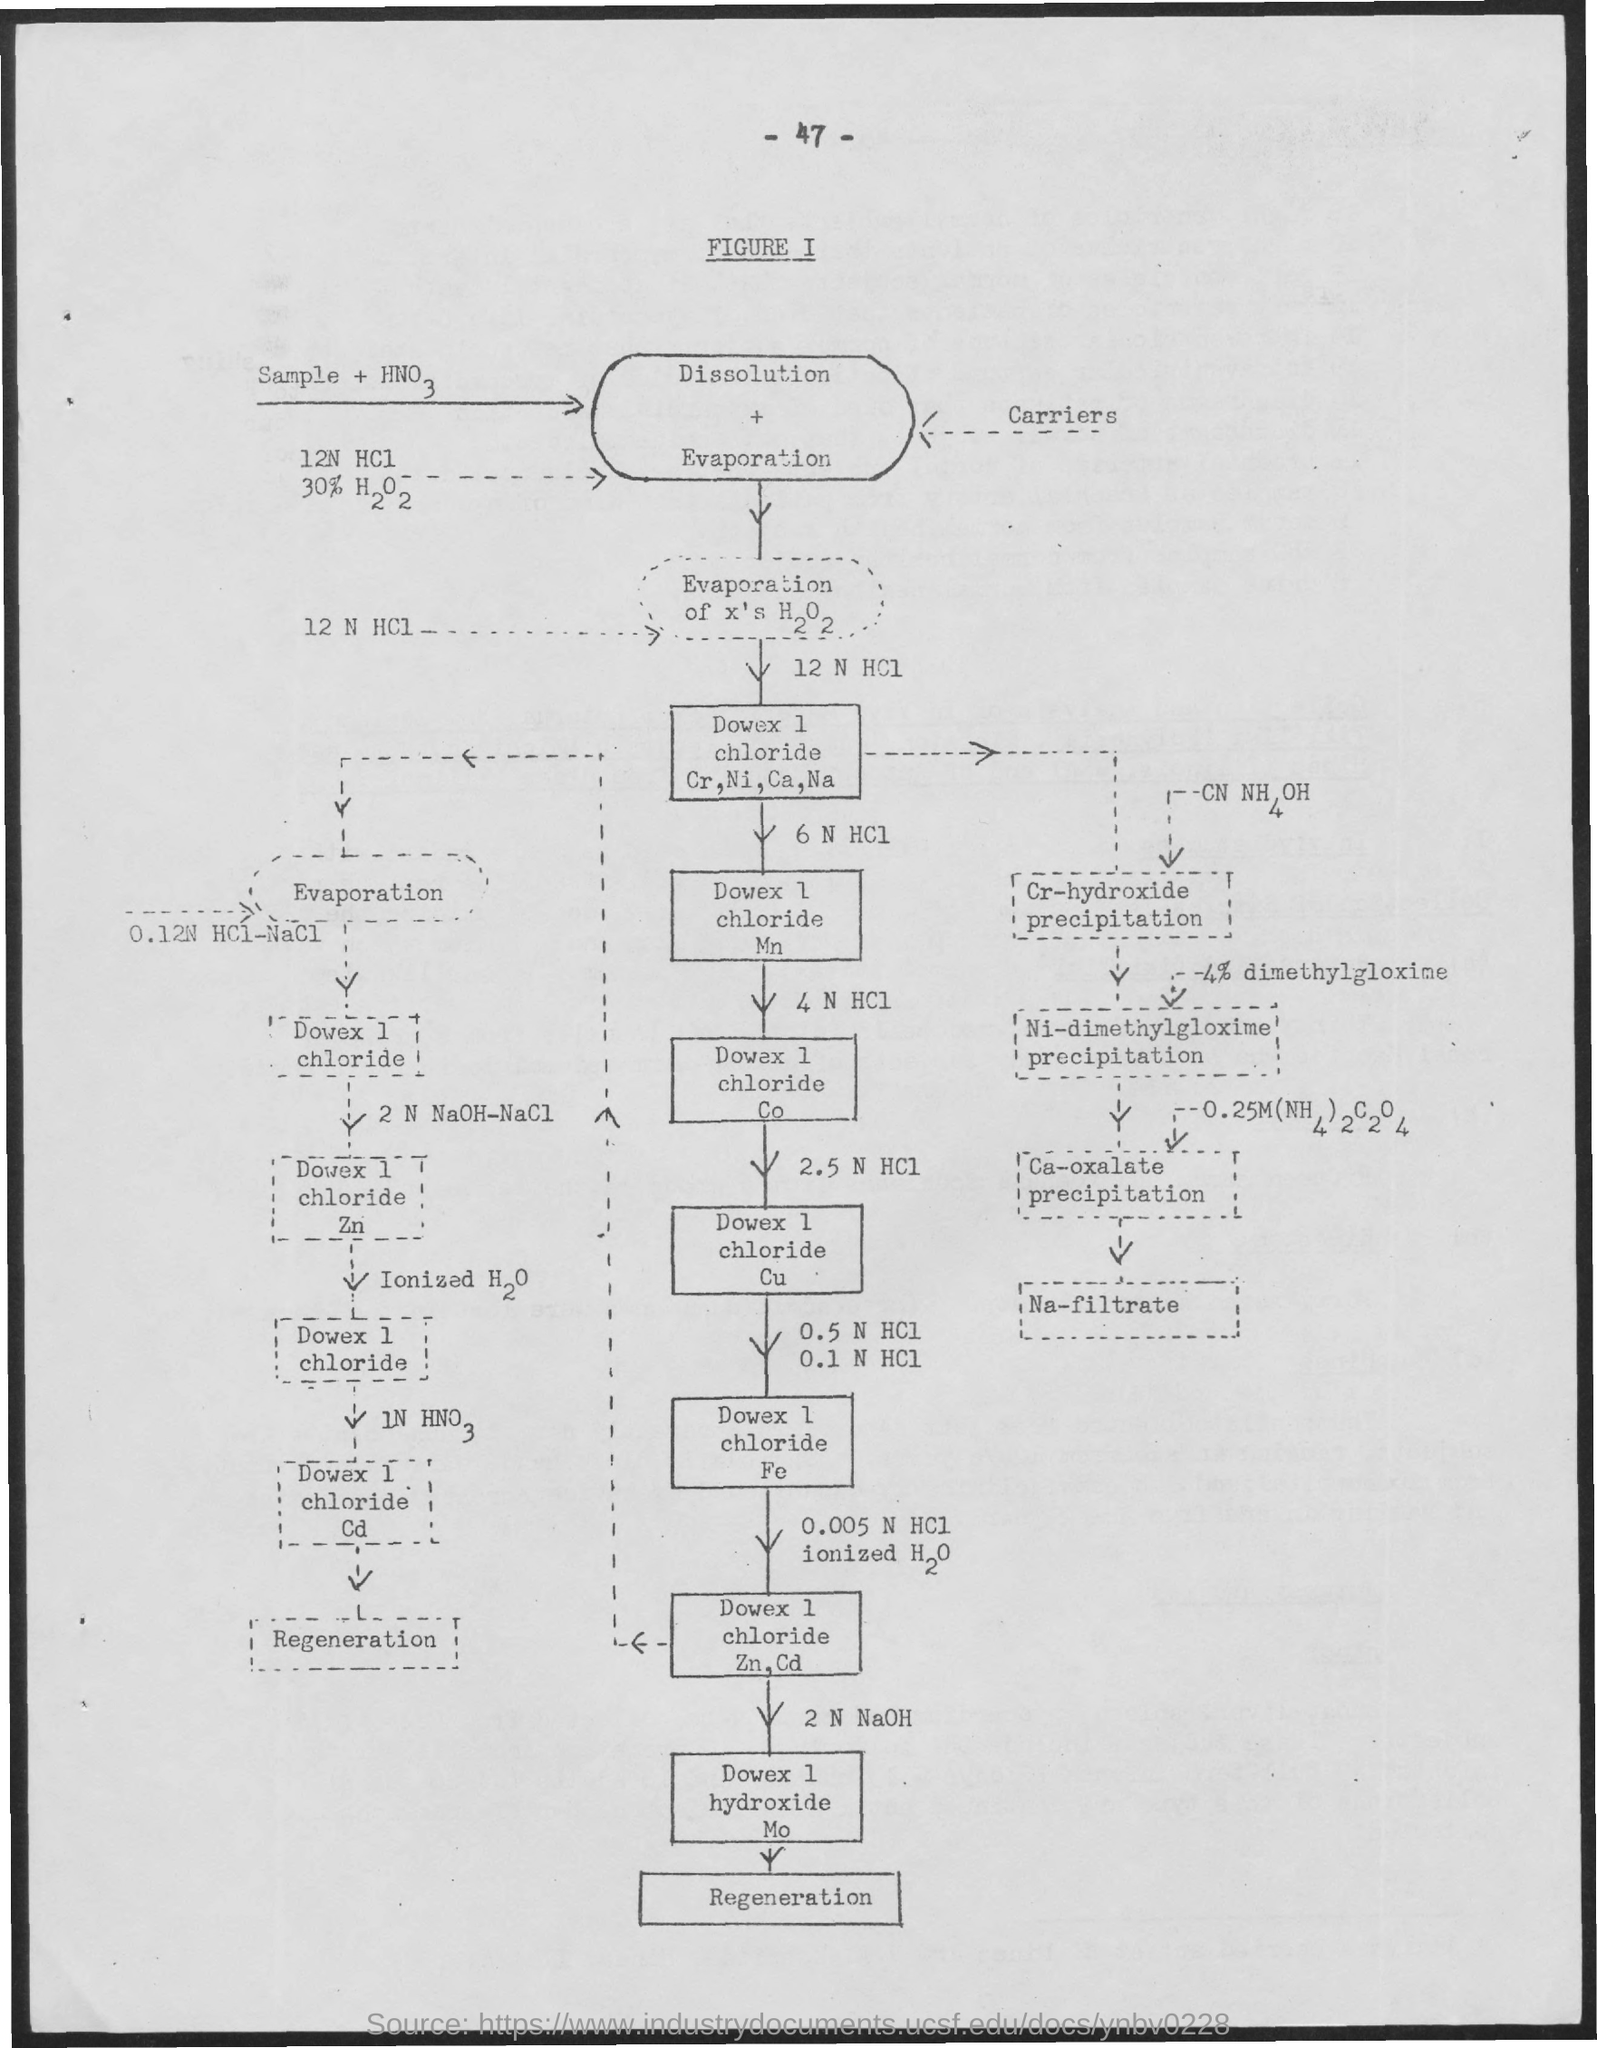What is the Page Number?
Offer a very short reply. 47. 